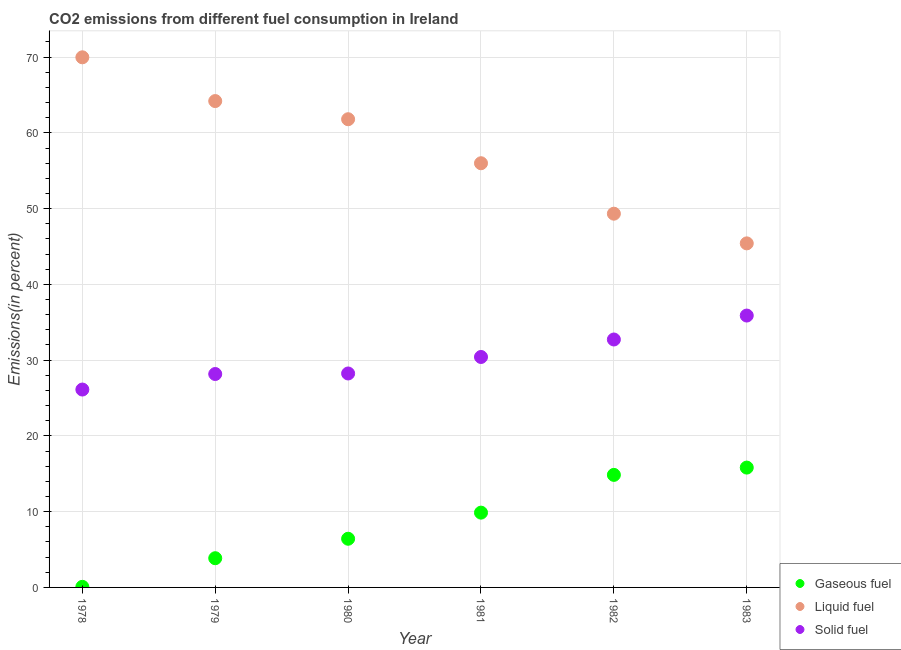Is the number of dotlines equal to the number of legend labels?
Your answer should be compact. Yes. What is the percentage of liquid fuel emission in 1979?
Provide a succinct answer. 64.2. Across all years, what is the maximum percentage of solid fuel emission?
Provide a short and direct response. 35.89. Across all years, what is the minimum percentage of liquid fuel emission?
Provide a short and direct response. 45.41. In which year was the percentage of gaseous fuel emission maximum?
Make the answer very short. 1983. In which year was the percentage of solid fuel emission minimum?
Ensure brevity in your answer.  1978. What is the total percentage of gaseous fuel emission in the graph?
Ensure brevity in your answer.  50.9. What is the difference between the percentage of liquid fuel emission in 1981 and that in 1983?
Offer a terse response. 10.58. What is the difference between the percentage of solid fuel emission in 1982 and the percentage of liquid fuel emission in 1981?
Give a very brief answer. -23.27. What is the average percentage of gaseous fuel emission per year?
Keep it short and to the point. 8.48. In the year 1980, what is the difference between the percentage of gaseous fuel emission and percentage of solid fuel emission?
Offer a very short reply. -21.82. What is the ratio of the percentage of liquid fuel emission in 1978 to that in 1982?
Keep it short and to the point. 1.42. What is the difference between the highest and the second highest percentage of solid fuel emission?
Ensure brevity in your answer.  3.16. What is the difference between the highest and the lowest percentage of solid fuel emission?
Provide a short and direct response. 9.77. Does the percentage of liquid fuel emission monotonically increase over the years?
Your answer should be compact. No. Is the percentage of liquid fuel emission strictly greater than the percentage of gaseous fuel emission over the years?
Ensure brevity in your answer.  Yes. Is the percentage of liquid fuel emission strictly less than the percentage of gaseous fuel emission over the years?
Your answer should be compact. No. How many dotlines are there?
Keep it short and to the point. 3. How many years are there in the graph?
Offer a very short reply. 6. What is the difference between two consecutive major ticks on the Y-axis?
Keep it short and to the point. 10. Are the values on the major ticks of Y-axis written in scientific E-notation?
Provide a short and direct response. No. Does the graph contain grids?
Keep it short and to the point. Yes. Where does the legend appear in the graph?
Offer a very short reply. Bottom right. What is the title of the graph?
Ensure brevity in your answer.  CO2 emissions from different fuel consumption in Ireland. What is the label or title of the Y-axis?
Your answer should be very brief. Emissions(in percent). What is the Emissions(in percent) of Gaseous fuel in 1978?
Give a very brief answer. 0.08. What is the Emissions(in percent) in Liquid fuel in 1978?
Your response must be concise. 69.98. What is the Emissions(in percent) in Solid fuel in 1978?
Keep it short and to the point. 26.12. What is the Emissions(in percent) of Gaseous fuel in 1979?
Your response must be concise. 3.86. What is the Emissions(in percent) in Liquid fuel in 1979?
Make the answer very short. 64.2. What is the Emissions(in percent) in Solid fuel in 1979?
Make the answer very short. 28.17. What is the Emissions(in percent) in Gaseous fuel in 1980?
Keep it short and to the point. 6.42. What is the Emissions(in percent) in Liquid fuel in 1980?
Offer a terse response. 61.8. What is the Emissions(in percent) in Solid fuel in 1980?
Your answer should be compact. 28.24. What is the Emissions(in percent) in Gaseous fuel in 1981?
Your answer should be very brief. 9.87. What is the Emissions(in percent) of Liquid fuel in 1981?
Provide a short and direct response. 55.99. What is the Emissions(in percent) in Solid fuel in 1981?
Provide a succinct answer. 30.42. What is the Emissions(in percent) in Gaseous fuel in 1982?
Offer a very short reply. 14.86. What is the Emissions(in percent) in Liquid fuel in 1982?
Keep it short and to the point. 49.33. What is the Emissions(in percent) of Solid fuel in 1982?
Your response must be concise. 32.73. What is the Emissions(in percent) of Gaseous fuel in 1983?
Make the answer very short. 15.82. What is the Emissions(in percent) in Liquid fuel in 1983?
Ensure brevity in your answer.  45.41. What is the Emissions(in percent) of Solid fuel in 1983?
Give a very brief answer. 35.89. Across all years, what is the maximum Emissions(in percent) of Gaseous fuel?
Offer a very short reply. 15.82. Across all years, what is the maximum Emissions(in percent) of Liquid fuel?
Keep it short and to the point. 69.98. Across all years, what is the maximum Emissions(in percent) in Solid fuel?
Keep it short and to the point. 35.89. Across all years, what is the minimum Emissions(in percent) in Gaseous fuel?
Offer a terse response. 0.08. Across all years, what is the minimum Emissions(in percent) in Liquid fuel?
Your answer should be very brief. 45.41. Across all years, what is the minimum Emissions(in percent) in Solid fuel?
Make the answer very short. 26.12. What is the total Emissions(in percent) in Gaseous fuel in the graph?
Offer a terse response. 50.9. What is the total Emissions(in percent) of Liquid fuel in the graph?
Provide a short and direct response. 346.71. What is the total Emissions(in percent) in Solid fuel in the graph?
Provide a short and direct response. 181.56. What is the difference between the Emissions(in percent) of Gaseous fuel in 1978 and that in 1979?
Offer a very short reply. -3.78. What is the difference between the Emissions(in percent) in Liquid fuel in 1978 and that in 1979?
Your answer should be compact. 5.78. What is the difference between the Emissions(in percent) of Solid fuel in 1978 and that in 1979?
Your answer should be compact. -2.05. What is the difference between the Emissions(in percent) in Gaseous fuel in 1978 and that in 1980?
Your response must be concise. -6.35. What is the difference between the Emissions(in percent) of Liquid fuel in 1978 and that in 1980?
Offer a terse response. 8.17. What is the difference between the Emissions(in percent) of Solid fuel in 1978 and that in 1980?
Your answer should be very brief. -2.12. What is the difference between the Emissions(in percent) in Gaseous fuel in 1978 and that in 1981?
Give a very brief answer. -9.79. What is the difference between the Emissions(in percent) of Liquid fuel in 1978 and that in 1981?
Your answer should be very brief. 13.98. What is the difference between the Emissions(in percent) in Solid fuel in 1978 and that in 1981?
Your response must be concise. -4.3. What is the difference between the Emissions(in percent) of Gaseous fuel in 1978 and that in 1982?
Offer a very short reply. -14.78. What is the difference between the Emissions(in percent) of Liquid fuel in 1978 and that in 1982?
Offer a terse response. 20.64. What is the difference between the Emissions(in percent) of Solid fuel in 1978 and that in 1982?
Provide a succinct answer. -6.61. What is the difference between the Emissions(in percent) of Gaseous fuel in 1978 and that in 1983?
Offer a terse response. -15.74. What is the difference between the Emissions(in percent) in Liquid fuel in 1978 and that in 1983?
Make the answer very short. 24.56. What is the difference between the Emissions(in percent) of Solid fuel in 1978 and that in 1983?
Make the answer very short. -9.77. What is the difference between the Emissions(in percent) of Gaseous fuel in 1979 and that in 1980?
Your answer should be compact. -2.57. What is the difference between the Emissions(in percent) of Liquid fuel in 1979 and that in 1980?
Give a very brief answer. 2.4. What is the difference between the Emissions(in percent) of Solid fuel in 1979 and that in 1980?
Give a very brief answer. -0.07. What is the difference between the Emissions(in percent) in Gaseous fuel in 1979 and that in 1981?
Your response must be concise. -6.02. What is the difference between the Emissions(in percent) in Liquid fuel in 1979 and that in 1981?
Your response must be concise. 8.21. What is the difference between the Emissions(in percent) of Solid fuel in 1979 and that in 1981?
Provide a short and direct response. -2.25. What is the difference between the Emissions(in percent) in Gaseous fuel in 1979 and that in 1982?
Provide a short and direct response. -11. What is the difference between the Emissions(in percent) of Liquid fuel in 1979 and that in 1982?
Give a very brief answer. 14.87. What is the difference between the Emissions(in percent) in Solid fuel in 1979 and that in 1982?
Provide a succinct answer. -4.56. What is the difference between the Emissions(in percent) in Gaseous fuel in 1979 and that in 1983?
Your answer should be very brief. -11.96. What is the difference between the Emissions(in percent) of Liquid fuel in 1979 and that in 1983?
Offer a very short reply. 18.78. What is the difference between the Emissions(in percent) of Solid fuel in 1979 and that in 1983?
Make the answer very short. -7.72. What is the difference between the Emissions(in percent) of Gaseous fuel in 1980 and that in 1981?
Give a very brief answer. -3.45. What is the difference between the Emissions(in percent) of Liquid fuel in 1980 and that in 1981?
Keep it short and to the point. 5.81. What is the difference between the Emissions(in percent) in Solid fuel in 1980 and that in 1981?
Keep it short and to the point. -2.18. What is the difference between the Emissions(in percent) of Gaseous fuel in 1980 and that in 1982?
Make the answer very short. -8.43. What is the difference between the Emissions(in percent) in Liquid fuel in 1980 and that in 1982?
Keep it short and to the point. 12.47. What is the difference between the Emissions(in percent) of Solid fuel in 1980 and that in 1982?
Give a very brief answer. -4.49. What is the difference between the Emissions(in percent) of Gaseous fuel in 1980 and that in 1983?
Your answer should be compact. -9.39. What is the difference between the Emissions(in percent) of Liquid fuel in 1980 and that in 1983?
Your answer should be very brief. 16.39. What is the difference between the Emissions(in percent) of Solid fuel in 1980 and that in 1983?
Give a very brief answer. -7.65. What is the difference between the Emissions(in percent) in Gaseous fuel in 1981 and that in 1982?
Offer a terse response. -4.98. What is the difference between the Emissions(in percent) of Liquid fuel in 1981 and that in 1982?
Ensure brevity in your answer.  6.66. What is the difference between the Emissions(in percent) in Solid fuel in 1981 and that in 1982?
Offer a very short reply. -2.31. What is the difference between the Emissions(in percent) in Gaseous fuel in 1981 and that in 1983?
Your answer should be compact. -5.95. What is the difference between the Emissions(in percent) in Liquid fuel in 1981 and that in 1983?
Your response must be concise. 10.58. What is the difference between the Emissions(in percent) of Solid fuel in 1981 and that in 1983?
Provide a succinct answer. -5.47. What is the difference between the Emissions(in percent) of Gaseous fuel in 1982 and that in 1983?
Your answer should be compact. -0.96. What is the difference between the Emissions(in percent) of Liquid fuel in 1982 and that in 1983?
Your answer should be compact. 3.92. What is the difference between the Emissions(in percent) in Solid fuel in 1982 and that in 1983?
Give a very brief answer. -3.16. What is the difference between the Emissions(in percent) of Gaseous fuel in 1978 and the Emissions(in percent) of Liquid fuel in 1979?
Provide a succinct answer. -64.12. What is the difference between the Emissions(in percent) of Gaseous fuel in 1978 and the Emissions(in percent) of Solid fuel in 1979?
Your answer should be very brief. -28.09. What is the difference between the Emissions(in percent) in Liquid fuel in 1978 and the Emissions(in percent) in Solid fuel in 1979?
Keep it short and to the point. 41.81. What is the difference between the Emissions(in percent) in Gaseous fuel in 1978 and the Emissions(in percent) in Liquid fuel in 1980?
Provide a succinct answer. -61.72. What is the difference between the Emissions(in percent) in Gaseous fuel in 1978 and the Emissions(in percent) in Solid fuel in 1980?
Make the answer very short. -28.16. What is the difference between the Emissions(in percent) of Liquid fuel in 1978 and the Emissions(in percent) of Solid fuel in 1980?
Your answer should be very brief. 41.73. What is the difference between the Emissions(in percent) in Gaseous fuel in 1978 and the Emissions(in percent) in Liquid fuel in 1981?
Provide a short and direct response. -55.91. What is the difference between the Emissions(in percent) of Gaseous fuel in 1978 and the Emissions(in percent) of Solid fuel in 1981?
Offer a terse response. -30.34. What is the difference between the Emissions(in percent) in Liquid fuel in 1978 and the Emissions(in percent) in Solid fuel in 1981?
Your response must be concise. 39.56. What is the difference between the Emissions(in percent) in Gaseous fuel in 1978 and the Emissions(in percent) in Liquid fuel in 1982?
Your response must be concise. -49.25. What is the difference between the Emissions(in percent) in Gaseous fuel in 1978 and the Emissions(in percent) in Solid fuel in 1982?
Offer a very short reply. -32.65. What is the difference between the Emissions(in percent) in Liquid fuel in 1978 and the Emissions(in percent) in Solid fuel in 1982?
Give a very brief answer. 37.25. What is the difference between the Emissions(in percent) of Gaseous fuel in 1978 and the Emissions(in percent) of Liquid fuel in 1983?
Your answer should be compact. -45.34. What is the difference between the Emissions(in percent) of Gaseous fuel in 1978 and the Emissions(in percent) of Solid fuel in 1983?
Your response must be concise. -35.81. What is the difference between the Emissions(in percent) in Liquid fuel in 1978 and the Emissions(in percent) in Solid fuel in 1983?
Provide a succinct answer. 34.09. What is the difference between the Emissions(in percent) of Gaseous fuel in 1979 and the Emissions(in percent) of Liquid fuel in 1980?
Offer a very short reply. -57.95. What is the difference between the Emissions(in percent) of Gaseous fuel in 1979 and the Emissions(in percent) of Solid fuel in 1980?
Provide a short and direct response. -24.38. What is the difference between the Emissions(in percent) of Liquid fuel in 1979 and the Emissions(in percent) of Solid fuel in 1980?
Offer a very short reply. 35.96. What is the difference between the Emissions(in percent) of Gaseous fuel in 1979 and the Emissions(in percent) of Liquid fuel in 1981?
Your response must be concise. -52.14. What is the difference between the Emissions(in percent) of Gaseous fuel in 1979 and the Emissions(in percent) of Solid fuel in 1981?
Keep it short and to the point. -26.56. What is the difference between the Emissions(in percent) in Liquid fuel in 1979 and the Emissions(in percent) in Solid fuel in 1981?
Ensure brevity in your answer.  33.78. What is the difference between the Emissions(in percent) in Gaseous fuel in 1979 and the Emissions(in percent) in Liquid fuel in 1982?
Provide a succinct answer. -45.48. What is the difference between the Emissions(in percent) of Gaseous fuel in 1979 and the Emissions(in percent) of Solid fuel in 1982?
Make the answer very short. -28.87. What is the difference between the Emissions(in percent) of Liquid fuel in 1979 and the Emissions(in percent) of Solid fuel in 1982?
Provide a succinct answer. 31.47. What is the difference between the Emissions(in percent) in Gaseous fuel in 1979 and the Emissions(in percent) in Liquid fuel in 1983?
Your answer should be very brief. -41.56. What is the difference between the Emissions(in percent) in Gaseous fuel in 1979 and the Emissions(in percent) in Solid fuel in 1983?
Your response must be concise. -32.03. What is the difference between the Emissions(in percent) of Liquid fuel in 1979 and the Emissions(in percent) of Solid fuel in 1983?
Your response must be concise. 28.31. What is the difference between the Emissions(in percent) of Gaseous fuel in 1980 and the Emissions(in percent) of Liquid fuel in 1981?
Provide a succinct answer. -49.57. What is the difference between the Emissions(in percent) in Gaseous fuel in 1980 and the Emissions(in percent) in Solid fuel in 1981?
Keep it short and to the point. -23.99. What is the difference between the Emissions(in percent) of Liquid fuel in 1980 and the Emissions(in percent) of Solid fuel in 1981?
Offer a very short reply. 31.38. What is the difference between the Emissions(in percent) in Gaseous fuel in 1980 and the Emissions(in percent) in Liquid fuel in 1982?
Your response must be concise. -42.91. What is the difference between the Emissions(in percent) of Gaseous fuel in 1980 and the Emissions(in percent) of Solid fuel in 1982?
Keep it short and to the point. -26.3. What is the difference between the Emissions(in percent) in Liquid fuel in 1980 and the Emissions(in percent) in Solid fuel in 1982?
Your answer should be compact. 29.08. What is the difference between the Emissions(in percent) of Gaseous fuel in 1980 and the Emissions(in percent) of Liquid fuel in 1983?
Your response must be concise. -38.99. What is the difference between the Emissions(in percent) in Gaseous fuel in 1980 and the Emissions(in percent) in Solid fuel in 1983?
Provide a short and direct response. -29.46. What is the difference between the Emissions(in percent) of Liquid fuel in 1980 and the Emissions(in percent) of Solid fuel in 1983?
Ensure brevity in your answer.  25.92. What is the difference between the Emissions(in percent) in Gaseous fuel in 1981 and the Emissions(in percent) in Liquid fuel in 1982?
Make the answer very short. -39.46. What is the difference between the Emissions(in percent) of Gaseous fuel in 1981 and the Emissions(in percent) of Solid fuel in 1982?
Ensure brevity in your answer.  -22.85. What is the difference between the Emissions(in percent) of Liquid fuel in 1981 and the Emissions(in percent) of Solid fuel in 1982?
Make the answer very short. 23.27. What is the difference between the Emissions(in percent) of Gaseous fuel in 1981 and the Emissions(in percent) of Liquid fuel in 1983?
Give a very brief answer. -35.54. What is the difference between the Emissions(in percent) in Gaseous fuel in 1981 and the Emissions(in percent) in Solid fuel in 1983?
Keep it short and to the point. -26.01. What is the difference between the Emissions(in percent) of Liquid fuel in 1981 and the Emissions(in percent) of Solid fuel in 1983?
Make the answer very short. 20.11. What is the difference between the Emissions(in percent) of Gaseous fuel in 1982 and the Emissions(in percent) of Liquid fuel in 1983?
Offer a very short reply. -30.56. What is the difference between the Emissions(in percent) of Gaseous fuel in 1982 and the Emissions(in percent) of Solid fuel in 1983?
Give a very brief answer. -21.03. What is the difference between the Emissions(in percent) of Liquid fuel in 1982 and the Emissions(in percent) of Solid fuel in 1983?
Give a very brief answer. 13.45. What is the average Emissions(in percent) in Gaseous fuel per year?
Keep it short and to the point. 8.48. What is the average Emissions(in percent) in Liquid fuel per year?
Keep it short and to the point. 57.79. What is the average Emissions(in percent) in Solid fuel per year?
Provide a short and direct response. 30.26. In the year 1978, what is the difference between the Emissions(in percent) in Gaseous fuel and Emissions(in percent) in Liquid fuel?
Ensure brevity in your answer.  -69.9. In the year 1978, what is the difference between the Emissions(in percent) in Gaseous fuel and Emissions(in percent) in Solid fuel?
Make the answer very short. -26.04. In the year 1978, what is the difference between the Emissions(in percent) in Liquid fuel and Emissions(in percent) in Solid fuel?
Provide a succinct answer. 43.85. In the year 1979, what is the difference between the Emissions(in percent) of Gaseous fuel and Emissions(in percent) of Liquid fuel?
Offer a terse response. -60.34. In the year 1979, what is the difference between the Emissions(in percent) in Gaseous fuel and Emissions(in percent) in Solid fuel?
Make the answer very short. -24.31. In the year 1979, what is the difference between the Emissions(in percent) of Liquid fuel and Emissions(in percent) of Solid fuel?
Your answer should be very brief. 36.03. In the year 1980, what is the difference between the Emissions(in percent) in Gaseous fuel and Emissions(in percent) in Liquid fuel?
Provide a succinct answer. -55.38. In the year 1980, what is the difference between the Emissions(in percent) in Gaseous fuel and Emissions(in percent) in Solid fuel?
Provide a succinct answer. -21.82. In the year 1980, what is the difference between the Emissions(in percent) in Liquid fuel and Emissions(in percent) in Solid fuel?
Provide a short and direct response. 33.56. In the year 1981, what is the difference between the Emissions(in percent) of Gaseous fuel and Emissions(in percent) of Liquid fuel?
Your answer should be very brief. -46.12. In the year 1981, what is the difference between the Emissions(in percent) of Gaseous fuel and Emissions(in percent) of Solid fuel?
Offer a terse response. -20.55. In the year 1981, what is the difference between the Emissions(in percent) in Liquid fuel and Emissions(in percent) in Solid fuel?
Offer a terse response. 25.57. In the year 1982, what is the difference between the Emissions(in percent) in Gaseous fuel and Emissions(in percent) in Liquid fuel?
Make the answer very short. -34.48. In the year 1982, what is the difference between the Emissions(in percent) of Gaseous fuel and Emissions(in percent) of Solid fuel?
Provide a succinct answer. -17.87. In the year 1982, what is the difference between the Emissions(in percent) of Liquid fuel and Emissions(in percent) of Solid fuel?
Keep it short and to the point. 16.61. In the year 1983, what is the difference between the Emissions(in percent) of Gaseous fuel and Emissions(in percent) of Liquid fuel?
Offer a terse response. -29.6. In the year 1983, what is the difference between the Emissions(in percent) in Gaseous fuel and Emissions(in percent) in Solid fuel?
Provide a short and direct response. -20.07. In the year 1983, what is the difference between the Emissions(in percent) in Liquid fuel and Emissions(in percent) in Solid fuel?
Your answer should be very brief. 9.53. What is the ratio of the Emissions(in percent) of Gaseous fuel in 1978 to that in 1979?
Your answer should be compact. 0.02. What is the ratio of the Emissions(in percent) of Liquid fuel in 1978 to that in 1979?
Your answer should be compact. 1.09. What is the ratio of the Emissions(in percent) of Solid fuel in 1978 to that in 1979?
Offer a terse response. 0.93. What is the ratio of the Emissions(in percent) of Gaseous fuel in 1978 to that in 1980?
Give a very brief answer. 0.01. What is the ratio of the Emissions(in percent) in Liquid fuel in 1978 to that in 1980?
Your answer should be very brief. 1.13. What is the ratio of the Emissions(in percent) of Solid fuel in 1978 to that in 1980?
Provide a succinct answer. 0.92. What is the ratio of the Emissions(in percent) of Gaseous fuel in 1978 to that in 1981?
Offer a very short reply. 0.01. What is the ratio of the Emissions(in percent) of Liquid fuel in 1978 to that in 1981?
Provide a short and direct response. 1.25. What is the ratio of the Emissions(in percent) in Solid fuel in 1978 to that in 1981?
Your response must be concise. 0.86. What is the ratio of the Emissions(in percent) of Gaseous fuel in 1978 to that in 1982?
Your answer should be compact. 0.01. What is the ratio of the Emissions(in percent) of Liquid fuel in 1978 to that in 1982?
Offer a terse response. 1.42. What is the ratio of the Emissions(in percent) in Solid fuel in 1978 to that in 1982?
Provide a short and direct response. 0.8. What is the ratio of the Emissions(in percent) of Gaseous fuel in 1978 to that in 1983?
Give a very brief answer. 0. What is the ratio of the Emissions(in percent) of Liquid fuel in 1978 to that in 1983?
Give a very brief answer. 1.54. What is the ratio of the Emissions(in percent) of Solid fuel in 1978 to that in 1983?
Provide a succinct answer. 0.73. What is the ratio of the Emissions(in percent) in Gaseous fuel in 1979 to that in 1980?
Your answer should be compact. 0.6. What is the ratio of the Emissions(in percent) in Liquid fuel in 1979 to that in 1980?
Make the answer very short. 1.04. What is the ratio of the Emissions(in percent) in Gaseous fuel in 1979 to that in 1981?
Your answer should be very brief. 0.39. What is the ratio of the Emissions(in percent) of Liquid fuel in 1979 to that in 1981?
Your answer should be very brief. 1.15. What is the ratio of the Emissions(in percent) of Solid fuel in 1979 to that in 1981?
Your answer should be compact. 0.93. What is the ratio of the Emissions(in percent) in Gaseous fuel in 1979 to that in 1982?
Make the answer very short. 0.26. What is the ratio of the Emissions(in percent) in Liquid fuel in 1979 to that in 1982?
Offer a terse response. 1.3. What is the ratio of the Emissions(in percent) in Solid fuel in 1979 to that in 1982?
Offer a terse response. 0.86. What is the ratio of the Emissions(in percent) of Gaseous fuel in 1979 to that in 1983?
Your answer should be compact. 0.24. What is the ratio of the Emissions(in percent) of Liquid fuel in 1979 to that in 1983?
Offer a terse response. 1.41. What is the ratio of the Emissions(in percent) of Solid fuel in 1979 to that in 1983?
Offer a very short reply. 0.79. What is the ratio of the Emissions(in percent) in Gaseous fuel in 1980 to that in 1981?
Offer a terse response. 0.65. What is the ratio of the Emissions(in percent) of Liquid fuel in 1980 to that in 1981?
Keep it short and to the point. 1.1. What is the ratio of the Emissions(in percent) of Solid fuel in 1980 to that in 1981?
Your answer should be very brief. 0.93. What is the ratio of the Emissions(in percent) of Gaseous fuel in 1980 to that in 1982?
Your answer should be compact. 0.43. What is the ratio of the Emissions(in percent) of Liquid fuel in 1980 to that in 1982?
Provide a short and direct response. 1.25. What is the ratio of the Emissions(in percent) of Solid fuel in 1980 to that in 1982?
Ensure brevity in your answer.  0.86. What is the ratio of the Emissions(in percent) in Gaseous fuel in 1980 to that in 1983?
Provide a succinct answer. 0.41. What is the ratio of the Emissions(in percent) of Liquid fuel in 1980 to that in 1983?
Provide a succinct answer. 1.36. What is the ratio of the Emissions(in percent) of Solid fuel in 1980 to that in 1983?
Offer a very short reply. 0.79. What is the ratio of the Emissions(in percent) of Gaseous fuel in 1981 to that in 1982?
Offer a terse response. 0.66. What is the ratio of the Emissions(in percent) in Liquid fuel in 1981 to that in 1982?
Provide a short and direct response. 1.14. What is the ratio of the Emissions(in percent) in Solid fuel in 1981 to that in 1982?
Your answer should be very brief. 0.93. What is the ratio of the Emissions(in percent) in Gaseous fuel in 1981 to that in 1983?
Keep it short and to the point. 0.62. What is the ratio of the Emissions(in percent) of Liquid fuel in 1981 to that in 1983?
Your answer should be compact. 1.23. What is the ratio of the Emissions(in percent) of Solid fuel in 1981 to that in 1983?
Offer a terse response. 0.85. What is the ratio of the Emissions(in percent) of Gaseous fuel in 1982 to that in 1983?
Ensure brevity in your answer.  0.94. What is the ratio of the Emissions(in percent) of Liquid fuel in 1982 to that in 1983?
Provide a short and direct response. 1.09. What is the ratio of the Emissions(in percent) in Solid fuel in 1982 to that in 1983?
Keep it short and to the point. 0.91. What is the difference between the highest and the second highest Emissions(in percent) in Gaseous fuel?
Ensure brevity in your answer.  0.96. What is the difference between the highest and the second highest Emissions(in percent) of Liquid fuel?
Your answer should be very brief. 5.78. What is the difference between the highest and the second highest Emissions(in percent) in Solid fuel?
Ensure brevity in your answer.  3.16. What is the difference between the highest and the lowest Emissions(in percent) in Gaseous fuel?
Make the answer very short. 15.74. What is the difference between the highest and the lowest Emissions(in percent) of Liquid fuel?
Offer a terse response. 24.56. What is the difference between the highest and the lowest Emissions(in percent) in Solid fuel?
Keep it short and to the point. 9.77. 